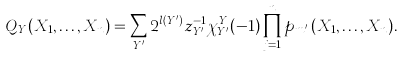<formula> <loc_0><loc_0><loc_500><loc_500>Q _ { Y } ( X _ { 1 } , \dots , X _ { n } ) = \sum _ { Y ^ { \prime } } 2 ^ { l ( Y ^ { \prime } ) } z _ { Y ^ { \prime } } ^ { - 1 } \chi ^ { Y } _ { Y ^ { \prime } } ( - 1 ) \prod _ { j = 1 } ^ { n } p _ { m _ { j } ^ { \prime } } ( X _ { 1 } , \dots , X _ { n } ) .</formula> 